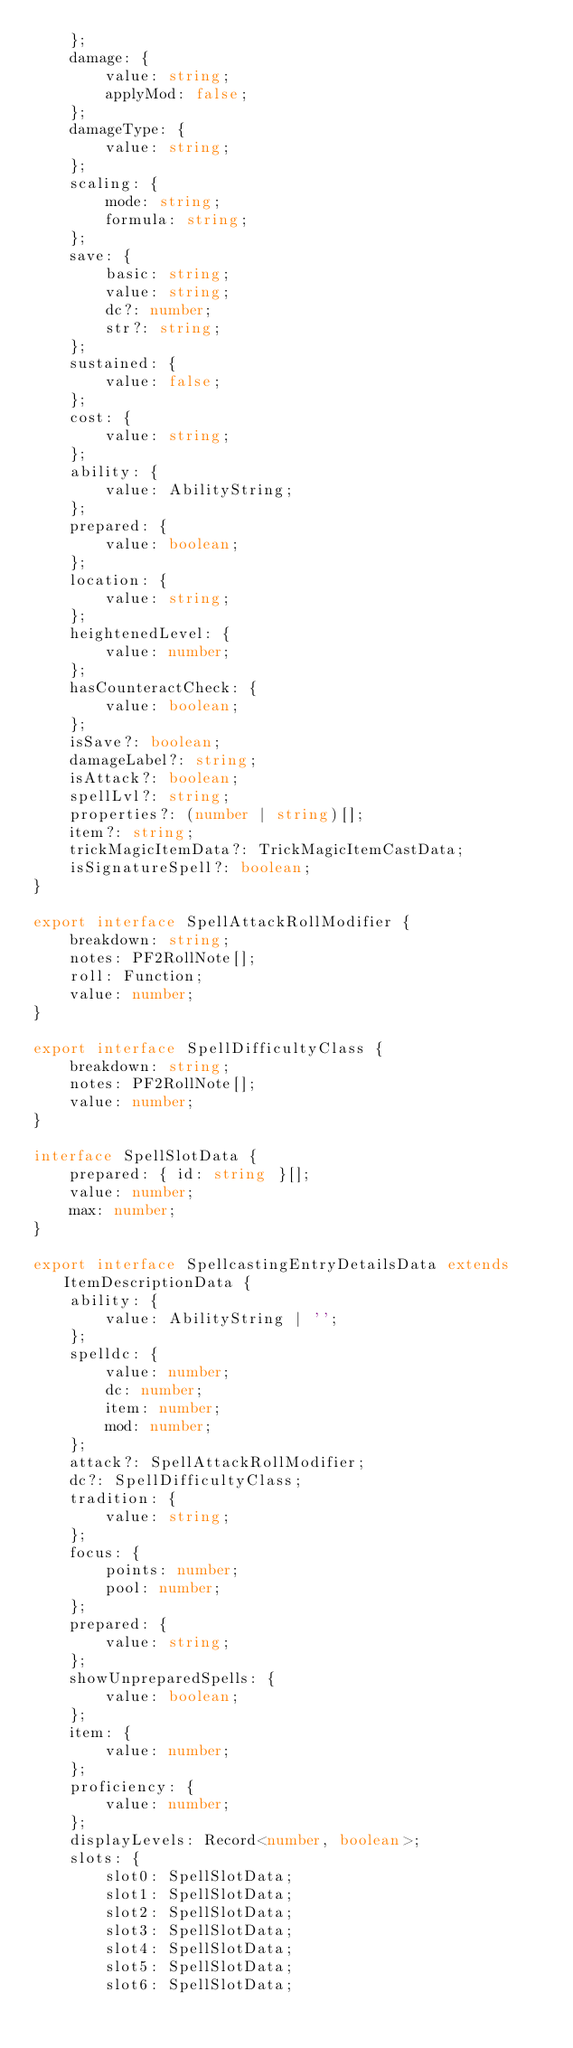<code> <loc_0><loc_0><loc_500><loc_500><_TypeScript_>    };
    damage: {
        value: string;
        applyMod: false;
    };
    damageType: {
        value: string;
    };
    scaling: {
        mode: string;
        formula: string;
    };
    save: {
        basic: string;
        value: string;
        dc?: number;
        str?: string;
    };
    sustained: {
        value: false;
    };
    cost: {
        value: string;
    };
    ability: {
        value: AbilityString;
    };
    prepared: {
        value: boolean;
    };
    location: {
        value: string;
    };
    heightenedLevel: {
        value: number;
    };
    hasCounteractCheck: {
        value: boolean;
    };
    isSave?: boolean;
    damageLabel?: string;
    isAttack?: boolean;
    spellLvl?: string;
    properties?: (number | string)[];
    item?: string;
    trickMagicItemData?: TrickMagicItemCastData;
    isSignatureSpell?: boolean;
}

export interface SpellAttackRollModifier {
    breakdown: string;
    notes: PF2RollNote[];
    roll: Function;
    value: number;
}

export interface SpellDifficultyClass {
    breakdown: string;
    notes: PF2RollNote[];
    value: number;
}

interface SpellSlotData {
    prepared: { id: string }[];
    value: number;
    max: number;
}

export interface SpellcastingEntryDetailsData extends ItemDescriptionData {
    ability: {
        value: AbilityString | '';
    };
    spelldc: {
        value: number;
        dc: number;
        item: number;
        mod: number;
    };
    attack?: SpellAttackRollModifier;
    dc?: SpellDifficultyClass;
    tradition: {
        value: string;
    };
    focus: {
        points: number;
        pool: number;
    };
    prepared: {
        value: string;
    };
    showUnpreparedSpells: {
        value: boolean;
    };
    item: {
        value: number;
    };
    proficiency: {
        value: number;
    };
    displayLevels: Record<number, boolean>;
    slots: {
        slot0: SpellSlotData;
        slot1: SpellSlotData;
        slot2: SpellSlotData;
        slot3: SpellSlotData;
        slot4: SpellSlotData;
        slot5: SpellSlotData;
        slot6: SpellSlotData;</code> 